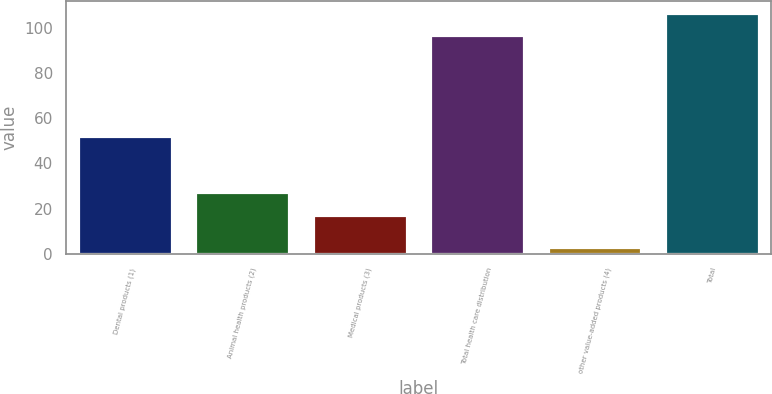Convert chart. <chart><loc_0><loc_0><loc_500><loc_500><bar_chart><fcel>Dental products (1)<fcel>Animal health products (2)<fcel>Medical products (3)<fcel>Total health care distribution<fcel>other value-added products (4)<fcel>Total<nl><fcel>52.3<fcel>27.2<fcel>17.2<fcel>96.7<fcel>3.3<fcel>106.37<nl></chart> 